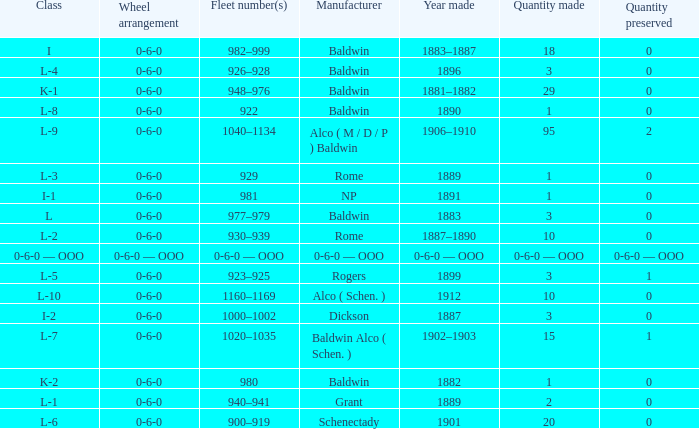Which Class has a Quantity made of 29? K-1. 